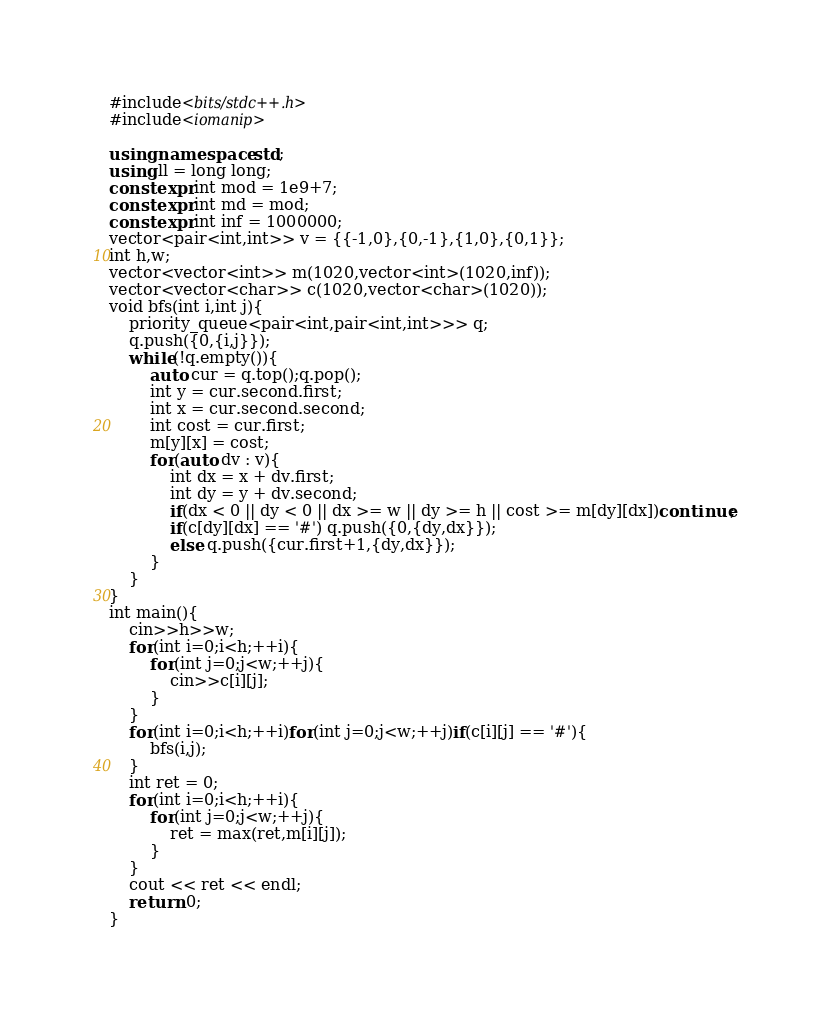<code> <loc_0><loc_0><loc_500><loc_500><_C++_>#include<bits/stdc++.h>
#include<iomanip>

using namespace std;
using ll = long long;
constexpr int mod = 1e9+7;
constexpr int md = mod;
constexpr int inf = 1000000;
vector<pair<int,int>> v = {{-1,0},{0,-1},{1,0},{0,1}};
int h,w;
vector<vector<int>> m(1020,vector<int>(1020,inf));
vector<vector<char>> c(1020,vector<char>(1020));
void bfs(int i,int j){
    priority_queue<pair<int,pair<int,int>>> q;
    q.push({0,{i,j}});
    while(!q.empty()){
        auto cur = q.top();q.pop();
        int y = cur.second.first;
        int x = cur.second.second;
        int cost = cur.first;
        m[y][x] = cost;
        for(auto dv : v){
            int dx = x + dv.first;
            int dy = y + dv.second;
            if(dx < 0 || dy < 0 || dx >= w || dy >= h || cost >= m[dy][dx])continue;
            if(c[dy][dx] == '#') q.push({0,{dy,dx}});
            else q.push({cur.first+1,{dy,dx}});
        }
    }
}
int main(){
    cin>>h>>w;
    for(int i=0;i<h;++i){
        for(int j=0;j<w;++j){
            cin>>c[i][j];
        }
    }
    for(int i=0;i<h;++i)for(int j=0;j<w;++j)if(c[i][j] == '#'){
        bfs(i,j);
    }
    int ret = 0;
    for(int i=0;i<h;++i){
        for(int j=0;j<w;++j){
            ret = max(ret,m[i][j]);
        }
    }
    cout << ret << endl;
    return 0;
}

</code> 